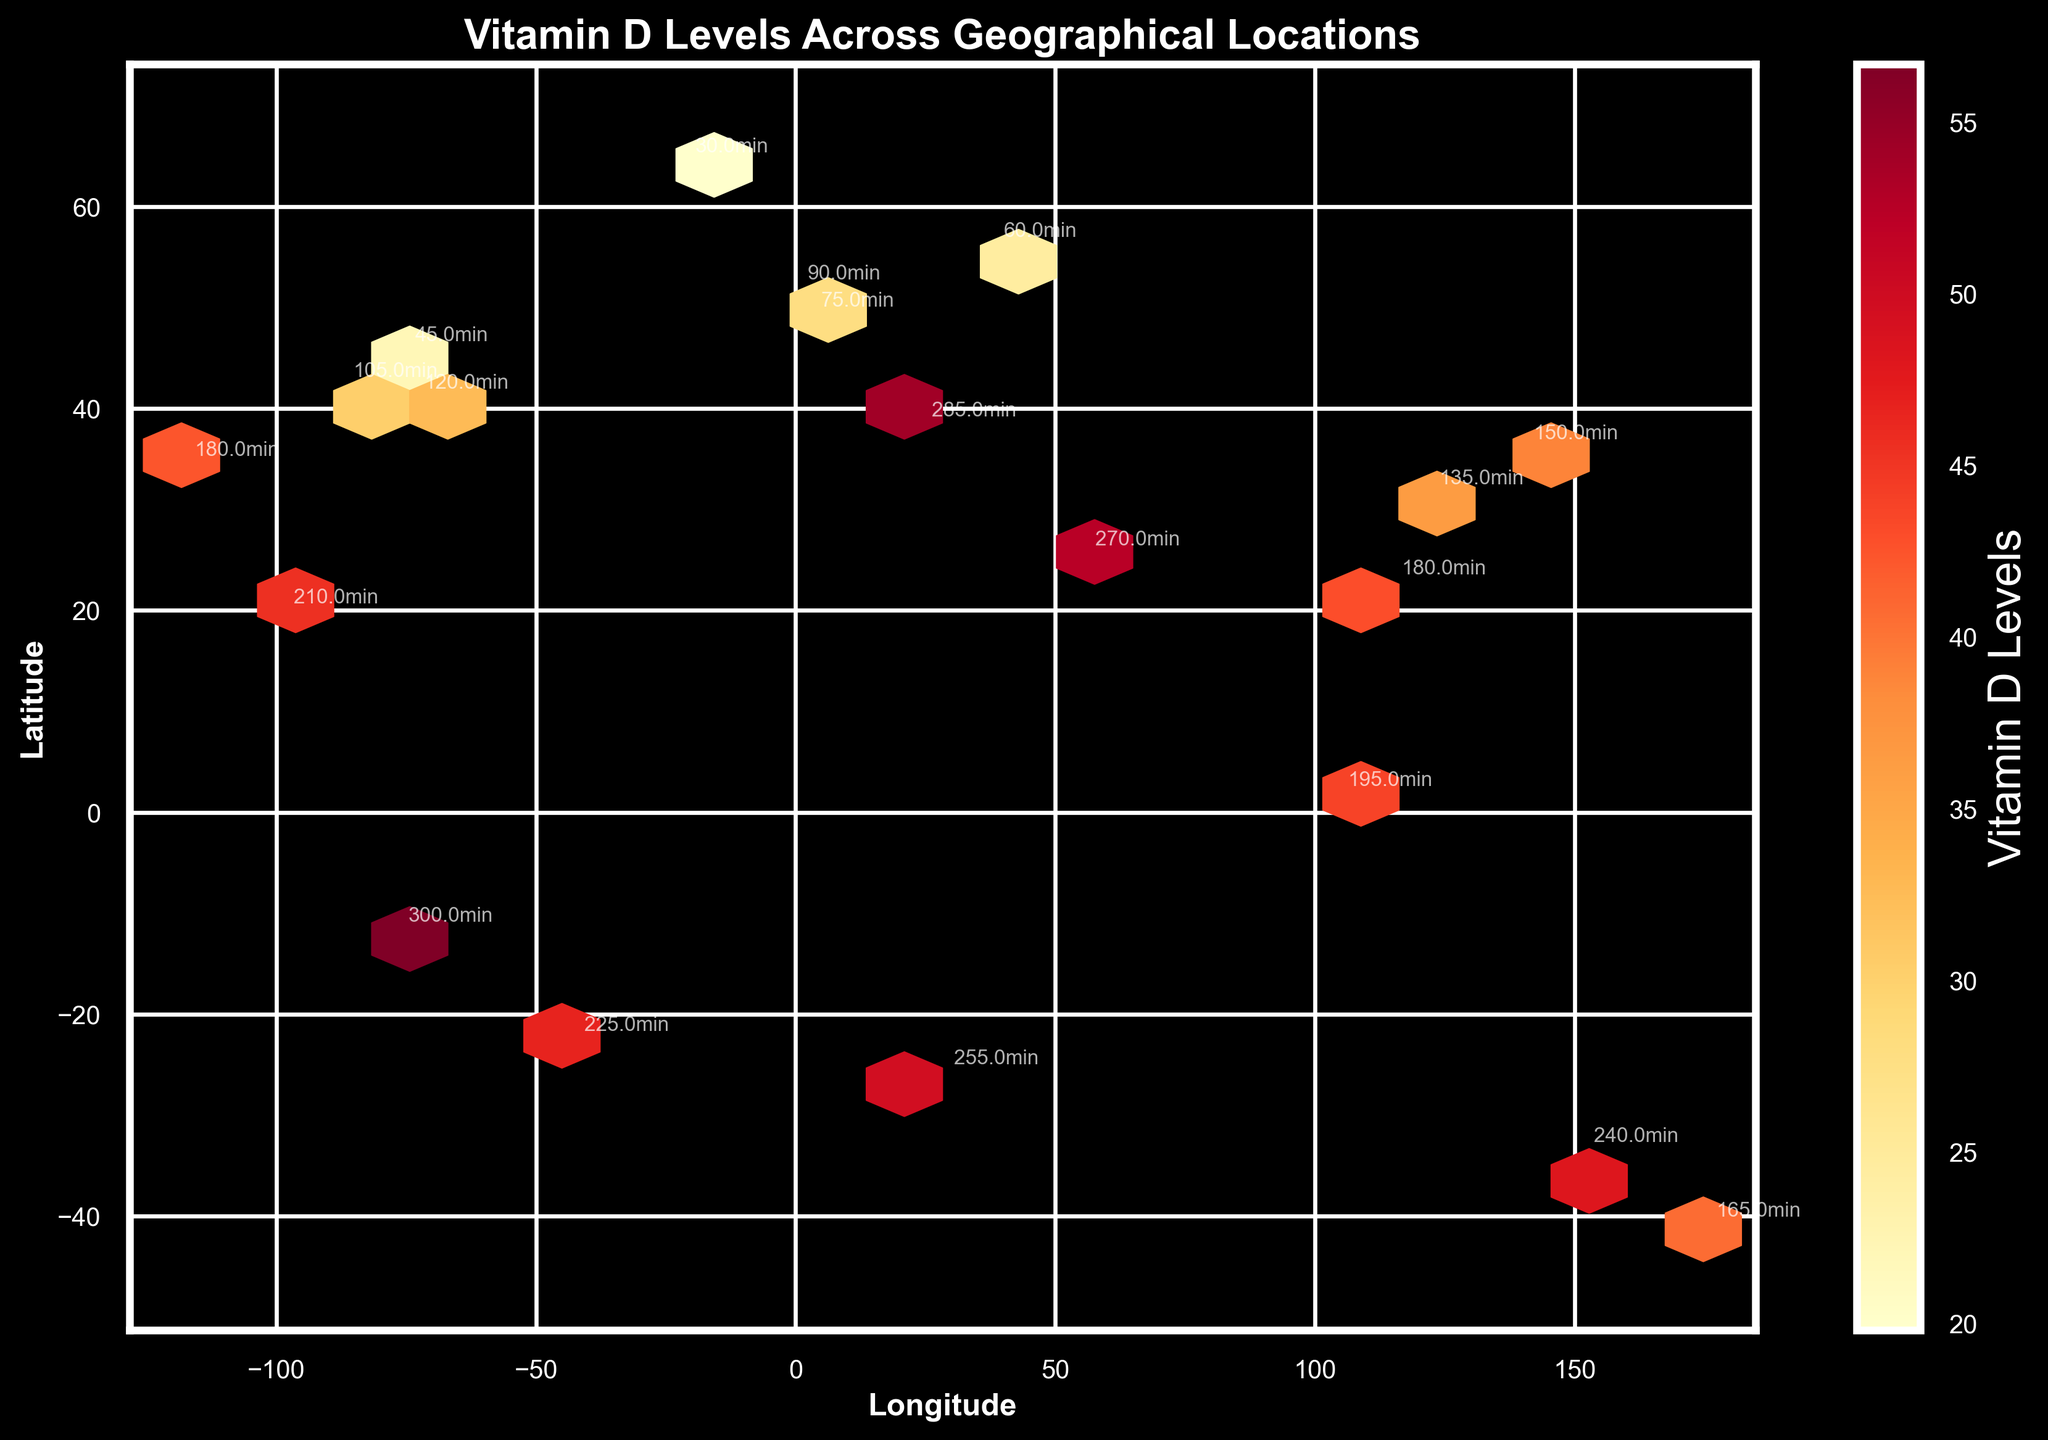What is the title of the Hexbin plot? The title of the plot is usually displayed at the top center. In this figure, it reads "Vitamin D Levels Across Geographical Locations."
Answer: Vitamin D Levels Across Geographical Locations How many minutes of outdoor activity were recorded for the data point at Longitude -74.0060 and Latitude 40.7128? Locate the coordinates (-74.0060, 40.7128) on the plot and find the annotation. The outdoor activity minutes should be labeled near the point.
Answer: 120min Which geographical location has the highest Vitamin D levels? Identify the hexbin with the highest color intensity. Refer to the color bar to determine the highest value. The annotation nearby will indicate the location with the maximum Vitamin D level.
Answer: -12.0464, -77.0428 On which axis is the longitude displayed? Axes are typically labeled. Look for the label closest to the x-axis region.
Answer: x-axis What is the Vitamin D level for the data point with 165 minutes of outdoor activity? Find the annotation for 165 minutes of outdoor activity. Then, match this point with the color intensity referencing the color bar for its exact value.
Answer: 40.6 How many geographical locations are there with outdoor activity minutes higher than 200? Inspect the annotations on the figure and count the number of points labeled with values greater than 200. Refer to "Outdoor_Activity_Minutes."
Answer: 6 Which geographical location has the smallest Vitamin D level, and what is its value? Identify the hexbin with the lowest color intensity. Use the color bar to find the lowest value and check the annotation to verify the exact location and value.
Answer: 64.1265, -21.8174; 19.8 Is there a trend observable between outdoor activity minutes and Vitamin D levels across the locations in the plot? Assess the increasing color intensity correlated with increasing annotations of outdoor activity minutes. This signifies a trend where more outdoor activity is associated with higher Vitamin D levels.
Answer: Yes, increasing trend Are there more data points in the Northern Hemisphere or the Southern Hemisphere? Count the number of data points (hexbins) annotated with minutes of outdoor activity on both sides of the equator (latitude 0). Compare the totals.
Answer: Northern Hemisphere 